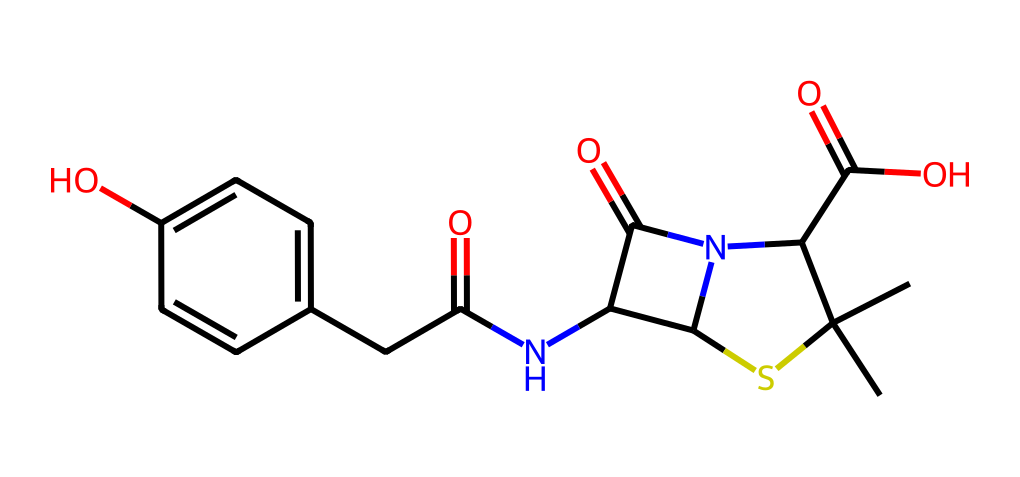What is the molecular formula of this chemical? To determine the molecular formula, I need to count the constituent atoms in the SMILES representation. By analyzing the chemical, I find it contains 18 carbon (C) atoms, 22 hydrogen (H) atoms, 4 nitrogen (N) atoms, 4 oxygen (O) atoms, and 1 sulfur (S) atom. Therefore, the molecular formula is C18H22N4O4S.
Answer: C18H22N4O4S How many nitrogen atoms are present? In the analysis of the given SMILES representation, by systematically identifying the nitrogen atoms present, I find there are 4 nitrogen (N) atoms in the structure.
Answer: 4 What chemical functionalities are present in this antibiotic? By closely examining the SMILES notation, I can identify functionalities such as amine (due to nitrogen), carboxylic acid (due to the -COOH group), and hydroxyl (due to -OH group). These functional groups indicate its properties as an antibiotic.
Answer: amine, carboxylic acid, hydroxyl What is the saturated state of this molecule? Analyzing the structure reveals that all carbon atoms are connected by single bonds or in the case of aromatic rings, they have delocalized electrons. This indicates that this molecule is not fully saturated due to the presence of C=C in the rings.
Answer: unsaturated What type of antibiotic does this molecule resemble? By examining the structural features and functional groups, I can deduce that the presence of a β-lactam structure indicates that it resembles penicillin, which is a common class of antibiotics.
Answer: penicillin Which part of this molecule indicates it can interact with bacterial cell walls? The β-lactam ring structure (identified by the cyclic arrangement and nitrogen) is crucial because it interacts with penicillin-binding proteins in bacterial cell walls, showing its mechanism of action as an antibiotic.
Answer: β-lactam ring What is the theoretical pKa of the carboxylic acid group? Analyzing the typical pKa values for carboxylic acids, which generally range from 4 to 5, I determine that the carboxylic acid group present in this compound will have a pKa in this range, meaning it is likely around 4.5.
Answer: 4.5 